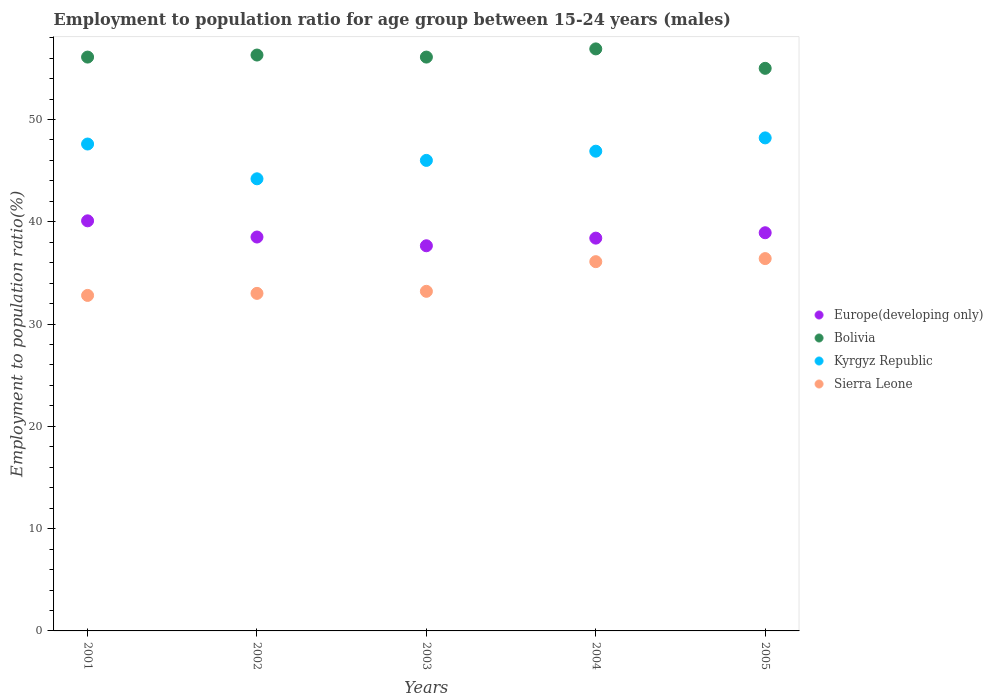What is the employment to population ratio in Sierra Leone in 2004?
Your answer should be very brief. 36.1. Across all years, what is the maximum employment to population ratio in Bolivia?
Your answer should be compact. 56.9. Across all years, what is the minimum employment to population ratio in Sierra Leone?
Offer a very short reply. 32.8. In which year was the employment to population ratio in Europe(developing only) maximum?
Provide a short and direct response. 2001. What is the total employment to population ratio in Kyrgyz Republic in the graph?
Make the answer very short. 232.9. What is the difference between the employment to population ratio in Kyrgyz Republic in 2001 and that in 2004?
Keep it short and to the point. 0.7. What is the difference between the employment to population ratio in Bolivia in 2001 and the employment to population ratio in Europe(developing only) in 2005?
Provide a short and direct response. 17.17. What is the average employment to population ratio in Bolivia per year?
Your answer should be compact. 56.08. In the year 2003, what is the difference between the employment to population ratio in Sierra Leone and employment to population ratio in Kyrgyz Republic?
Your answer should be very brief. -12.8. In how many years, is the employment to population ratio in Europe(developing only) greater than 24 %?
Keep it short and to the point. 5. What is the ratio of the employment to population ratio in Bolivia in 2002 to that in 2005?
Your response must be concise. 1.02. Is the employment to population ratio in Kyrgyz Republic in 2003 less than that in 2005?
Your answer should be very brief. Yes. What is the difference between the highest and the second highest employment to population ratio in Europe(developing only)?
Give a very brief answer. 1.16. What is the difference between the highest and the lowest employment to population ratio in Sierra Leone?
Offer a very short reply. 3.6. In how many years, is the employment to population ratio in Sierra Leone greater than the average employment to population ratio in Sierra Leone taken over all years?
Ensure brevity in your answer.  2. Is it the case that in every year, the sum of the employment to population ratio in Kyrgyz Republic and employment to population ratio in Europe(developing only)  is greater than the sum of employment to population ratio in Sierra Leone and employment to population ratio in Bolivia?
Ensure brevity in your answer.  No. What is the difference between two consecutive major ticks on the Y-axis?
Your response must be concise. 10. Where does the legend appear in the graph?
Make the answer very short. Center right. How many legend labels are there?
Your answer should be very brief. 4. How are the legend labels stacked?
Give a very brief answer. Vertical. What is the title of the graph?
Provide a short and direct response. Employment to population ratio for age group between 15-24 years (males). Does "Denmark" appear as one of the legend labels in the graph?
Provide a short and direct response. No. What is the label or title of the X-axis?
Your answer should be very brief. Years. What is the Employment to population ratio(%) of Europe(developing only) in 2001?
Your answer should be compact. 40.09. What is the Employment to population ratio(%) in Bolivia in 2001?
Give a very brief answer. 56.1. What is the Employment to population ratio(%) in Kyrgyz Republic in 2001?
Give a very brief answer. 47.6. What is the Employment to population ratio(%) in Sierra Leone in 2001?
Offer a very short reply. 32.8. What is the Employment to population ratio(%) of Europe(developing only) in 2002?
Give a very brief answer. 38.51. What is the Employment to population ratio(%) in Bolivia in 2002?
Make the answer very short. 56.3. What is the Employment to population ratio(%) of Kyrgyz Republic in 2002?
Keep it short and to the point. 44.2. What is the Employment to population ratio(%) of Sierra Leone in 2002?
Provide a succinct answer. 33. What is the Employment to population ratio(%) in Europe(developing only) in 2003?
Provide a short and direct response. 37.65. What is the Employment to population ratio(%) in Bolivia in 2003?
Provide a short and direct response. 56.1. What is the Employment to population ratio(%) of Sierra Leone in 2003?
Keep it short and to the point. 33.2. What is the Employment to population ratio(%) in Europe(developing only) in 2004?
Your answer should be compact. 38.4. What is the Employment to population ratio(%) of Bolivia in 2004?
Your response must be concise. 56.9. What is the Employment to population ratio(%) of Kyrgyz Republic in 2004?
Your answer should be very brief. 46.9. What is the Employment to population ratio(%) in Sierra Leone in 2004?
Your response must be concise. 36.1. What is the Employment to population ratio(%) of Europe(developing only) in 2005?
Your response must be concise. 38.93. What is the Employment to population ratio(%) in Bolivia in 2005?
Provide a short and direct response. 55. What is the Employment to population ratio(%) in Kyrgyz Republic in 2005?
Keep it short and to the point. 48.2. What is the Employment to population ratio(%) in Sierra Leone in 2005?
Provide a succinct answer. 36.4. Across all years, what is the maximum Employment to population ratio(%) in Europe(developing only)?
Offer a very short reply. 40.09. Across all years, what is the maximum Employment to population ratio(%) of Bolivia?
Offer a very short reply. 56.9. Across all years, what is the maximum Employment to population ratio(%) of Kyrgyz Republic?
Provide a short and direct response. 48.2. Across all years, what is the maximum Employment to population ratio(%) in Sierra Leone?
Your answer should be compact. 36.4. Across all years, what is the minimum Employment to population ratio(%) in Europe(developing only)?
Keep it short and to the point. 37.65. Across all years, what is the minimum Employment to population ratio(%) of Bolivia?
Your answer should be compact. 55. Across all years, what is the minimum Employment to population ratio(%) in Kyrgyz Republic?
Your answer should be compact. 44.2. Across all years, what is the minimum Employment to population ratio(%) of Sierra Leone?
Provide a succinct answer. 32.8. What is the total Employment to population ratio(%) of Europe(developing only) in the graph?
Provide a succinct answer. 193.58. What is the total Employment to population ratio(%) of Bolivia in the graph?
Provide a short and direct response. 280.4. What is the total Employment to population ratio(%) of Kyrgyz Republic in the graph?
Give a very brief answer. 232.9. What is the total Employment to population ratio(%) in Sierra Leone in the graph?
Your response must be concise. 171.5. What is the difference between the Employment to population ratio(%) of Europe(developing only) in 2001 and that in 2002?
Offer a terse response. 1.58. What is the difference between the Employment to population ratio(%) in Bolivia in 2001 and that in 2002?
Provide a short and direct response. -0.2. What is the difference between the Employment to population ratio(%) of Sierra Leone in 2001 and that in 2002?
Your response must be concise. -0.2. What is the difference between the Employment to population ratio(%) in Europe(developing only) in 2001 and that in 2003?
Offer a terse response. 2.44. What is the difference between the Employment to population ratio(%) in Kyrgyz Republic in 2001 and that in 2003?
Ensure brevity in your answer.  1.6. What is the difference between the Employment to population ratio(%) of Europe(developing only) in 2001 and that in 2004?
Give a very brief answer. 1.69. What is the difference between the Employment to population ratio(%) of Bolivia in 2001 and that in 2004?
Provide a short and direct response. -0.8. What is the difference between the Employment to population ratio(%) of Europe(developing only) in 2001 and that in 2005?
Keep it short and to the point. 1.16. What is the difference between the Employment to population ratio(%) of Bolivia in 2001 and that in 2005?
Your answer should be very brief. 1.1. What is the difference between the Employment to population ratio(%) of Kyrgyz Republic in 2001 and that in 2005?
Offer a very short reply. -0.6. What is the difference between the Employment to population ratio(%) in Sierra Leone in 2001 and that in 2005?
Your answer should be very brief. -3.6. What is the difference between the Employment to population ratio(%) in Europe(developing only) in 2002 and that in 2003?
Offer a very short reply. 0.86. What is the difference between the Employment to population ratio(%) of Sierra Leone in 2002 and that in 2003?
Provide a short and direct response. -0.2. What is the difference between the Employment to population ratio(%) of Europe(developing only) in 2002 and that in 2004?
Offer a very short reply. 0.11. What is the difference between the Employment to population ratio(%) in Kyrgyz Republic in 2002 and that in 2004?
Offer a terse response. -2.7. What is the difference between the Employment to population ratio(%) of Europe(developing only) in 2002 and that in 2005?
Your answer should be very brief. -0.42. What is the difference between the Employment to population ratio(%) of Kyrgyz Republic in 2002 and that in 2005?
Give a very brief answer. -4. What is the difference between the Employment to population ratio(%) in Europe(developing only) in 2003 and that in 2004?
Give a very brief answer. -0.75. What is the difference between the Employment to population ratio(%) in Europe(developing only) in 2003 and that in 2005?
Your answer should be compact. -1.27. What is the difference between the Employment to population ratio(%) of Bolivia in 2003 and that in 2005?
Offer a terse response. 1.1. What is the difference between the Employment to population ratio(%) in Kyrgyz Republic in 2003 and that in 2005?
Offer a very short reply. -2.2. What is the difference between the Employment to population ratio(%) in Europe(developing only) in 2004 and that in 2005?
Your response must be concise. -0.53. What is the difference between the Employment to population ratio(%) in Europe(developing only) in 2001 and the Employment to population ratio(%) in Bolivia in 2002?
Your response must be concise. -16.21. What is the difference between the Employment to population ratio(%) of Europe(developing only) in 2001 and the Employment to population ratio(%) of Kyrgyz Republic in 2002?
Provide a succinct answer. -4.11. What is the difference between the Employment to population ratio(%) in Europe(developing only) in 2001 and the Employment to population ratio(%) in Sierra Leone in 2002?
Ensure brevity in your answer.  7.09. What is the difference between the Employment to population ratio(%) of Bolivia in 2001 and the Employment to population ratio(%) of Kyrgyz Republic in 2002?
Your answer should be very brief. 11.9. What is the difference between the Employment to population ratio(%) in Bolivia in 2001 and the Employment to population ratio(%) in Sierra Leone in 2002?
Give a very brief answer. 23.1. What is the difference between the Employment to population ratio(%) in Kyrgyz Republic in 2001 and the Employment to population ratio(%) in Sierra Leone in 2002?
Your response must be concise. 14.6. What is the difference between the Employment to population ratio(%) in Europe(developing only) in 2001 and the Employment to population ratio(%) in Bolivia in 2003?
Your answer should be compact. -16.01. What is the difference between the Employment to population ratio(%) in Europe(developing only) in 2001 and the Employment to population ratio(%) in Kyrgyz Republic in 2003?
Provide a succinct answer. -5.91. What is the difference between the Employment to population ratio(%) in Europe(developing only) in 2001 and the Employment to population ratio(%) in Sierra Leone in 2003?
Provide a short and direct response. 6.89. What is the difference between the Employment to population ratio(%) in Bolivia in 2001 and the Employment to population ratio(%) in Sierra Leone in 2003?
Offer a terse response. 22.9. What is the difference between the Employment to population ratio(%) of Europe(developing only) in 2001 and the Employment to population ratio(%) of Bolivia in 2004?
Ensure brevity in your answer.  -16.81. What is the difference between the Employment to population ratio(%) in Europe(developing only) in 2001 and the Employment to population ratio(%) in Kyrgyz Republic in 2004?
Your answer should be very brief. -6.81. What is the difference between the Employment to population ratio(%) in Europe(developing only) in 2001 and the Employment to population ratio(%) in Sierra Leone in 2004?
Offer a terse response. 3.99. What is the difference between the Employment to population ratio(%) of Europe(developing only) in 2001 and the Employment to population ratio(%) of Bolivia in 2005?
Give a very brief answer. -14.91. What is the difference between the Employment to population ratio(%) in Europe(developing only) in 2001 and the Employment to population ratio(%) in Kyrgyz Republic in 2005?
Your answer should be compact. -8.11. What is the difference between the Employment to population ratio(%) of Europe(developing only) in 2001 and the Employment to population ratio(%) of Sierra Leone in 2005?
Your response must be concise. 3.69. What is the difference between the Employment to population ratio(%) of Bolivia in 2001 and the Employment to population ratio(%) of Kyrgyz Republic in 2005?
Provide a short and direct response. 7.9. What is the difference between the Employment to population ratio(%) of Europe(developing only) in 2002 and the Employment to population ratio(%) of Bolivia in 2003?
Your answer should be very brief. -17.59. What is the difference between the Employment to population ratio(%) of Europe(developing only) in 2002 and the Employment to population ratio(%) of Kyrgyz Republic in 2003?
Provide a short and direct response. -7.49. What is the difference between the Employment to population ratio(%) in Europe(developing only) in 2002 and the Employment to population ratio(%) in Sierra Leone in 2003?
Provide a succinct answer. 5.31. What is the difference between the Employment to population ratio(%) in Bolivia in 2002 and the Employment to population ratio(%) in Kyrgyz Republic in 2003?
Your answer should be compact. 10.3. What is the difference between the Employment to population ratio(%) of Bolivia in 2002 and the Employment to population ratio(%) of Sierra Leone in 2003?
Provide a succinct answer. 23.1. What is the difference between the Employment to population ratio(%) in Europe(developing only) in 2002 and the Employment to population ratio(%) in Bolivia in 2004?
Keep it short and to the point. -18.39. What is the difference between the Employment to population ratio(%) in Europe(developing only) in 2002 and the Employment to population ratio(%) in Kyrgyz Republic in 2004?
Your answer should be very brief. -8.39. What is the difference between the Employment to population ratio(%) in Europe(developing only) in 2002 and the Employment to population ratio(%) in Sierra Leone in 2004?
Your response must be concise. 2.41. What is the difference between the Employment to population ratio(%) in Bolivia in 2002 and the Employment to population ratio(%) in Sierra Leone in 2004?
Make the answer very short. 20.2. What is the difference between the Employment to population ratio(%) of Europe(developing only) in 2002 and the Employment to population ratio(%) of Bolivia in 2005?
Offer a terse response. -16.49. What is the difference between the Employment to population ratio(%) in Europe(developing only) in 2002 and the Employment to population ratio(%) in Kyrgyz Republic in 2005?
Your answer should be very brief. -9.69. What is the difference between the Employment to population ratio(%) in Europe(developing only) in 2002 and the Employment to population ratio(%) in Sierra Leone in 2005?
Provide a succinct answer. 2.11. What is the difference between the Employment to population ratio(%) in Europe(developing only) in 2003 and the Employment to population ratio(%) in Bolivia in 2004?
Your answer should be compact. -19.25. What is the difference between the Employment to population ratio(%) of Europe(developing only) in 2003 and the Employment to population ratio(%) of Kyrgyz Republic in 2004?
Give a very brief answer. -9.25. What is the difference between the Employment to population ratio(%) in Europe(developing only) in 2003 and the Employment to population ratio(%) in Sierra Leone in 2004?
Offer a very short reply. 1.55. What is the difference between the Employment to population ratio(%) in Bolivia in 2003 and the Employment to population ratio(%) in Kyrgyz Republic in 2004?
Provide a succinct answer. 9.2. What is the difference between the Employment to population ratio(%) of Bolivia in 2003 and the Employment to population ratio(%) of Sierra Leone in 2004?
Your answer should be very brief. 20. What is the difference between the Employment to population ratio(%) of Europe(developing only) in 2003 and the Employment to population ratio(%) of Bolivia in 2005?
Ensure brevity in your answer.  -17.35. What is the difference between the Employment to population ratio(%) of Europe(developing only) in 2003 and the Employment to population ratio(%) of Kyrgyz Republic in 2005?
Ensure brevity in your answer.  -10.55. What is the difference between the Employment to population ratio(%) of Europe(developing only) in 2003 and the Employment to population ratio(%) of Sierra Leone in 2005?
Your answer should be very brief. 1.25. What is the difference between the Employment to population ratio(%) of Bolivia in 2003 and the Employment to population ratio(%) of Kyrgyz Republic in 2005?
Offer a terse response. 7.9. What is the difference between the Employment to population ratio(%) of Bolivia in 2003 and the Employment to population ratio(%) of Sierra Leone in 2005?
Provide a short and direct response. 19.7. What is the difference between the Employment to population ratio(%) of Europe(developing only) in 2004 and the Employment to population ratio(%) of Bolivia in 2005?
Your response must be concise. -16.6. What is the difference between the Employment to population ratio(%) in Europe(developing only) in 2004 and the Employment to population ratio(%) in Kyrgyz Republic in 2005?
Your answer should be very brief. -9.8. What is the difference between the Employment to population ratio(%) in Europe(developing only) in 2004 and the Employment to population ratio(%) in Sierra Leone in 2005?
Give a very brief answer. 2. What is the difference between the Employment to population ratio(%) of Bolivia in 2004 and the Employment to population ratio(%) of Kyrgyz Republic in 2005?
Ensure brevity in your answer.  8.7. What is the difference between the Employment to population ratio(%) in Bolivia in 2004 and the Employment to population ratio(%) in Sierra Leone in 2005?
Your response must be concise. 20.5. What is the difference between the Employment to population ratio(%) in Kyrgyz Republic in 2004 and the Employment to population ratio(%) in Sierra Leone in 2005?
Give a very brief answer. 10.5. What is the average Employment to population ratio(%) of Europe(developing only) per year?
Keep it short and to the point. 38.72. What is the average Employment to population ratio(%) in Bolivia per year?
Provide a short and direct response. 56.08. What is the average Employment to population ratio(%) in Kyrgyz Republic per year?
Make the answer very short. 46.58. What is the average Employment to population ratio(%) in Sierra Leone per year?
Give a very brief answer. 34.3. In the year 2001, what is the difference between the Employment to population ratio(%) in Europe(developing only) and Employment to population ratio(%) in Bolivia?
Provide a succinct answer. -16.01. In the year 2001, what is the difference between the Employment to population ratio(%) of Europe(developing only) and Employment to population ratio(%) of Kyrgyz Republic?
Give a very brief answer. -7.51. In the year 2001, what is the difference between the Employment to population ratio(%) in Europe(developing only) and Employment to population ratio(%) in Sierra Leone?
Offer a very short reply. 7.29. In the year 2001, what is the difference between the Employment to population ratio(%) in Bolivia and Employment to population ratio(%) in Sierra Leone?
Offer a terse response. 23.3. In the year 2002, what is the difference between the Employment to population ratio(%) of Europe(developing only) and Employment to population ratio(%) of Bolivia?
Ensure brevity in your answer.  -17.79. In the year 2002, what is the difference between the Employment to population ratio(%) of Europe(developing only) and Employment to population ratio(%) of Kyrgyz Republic?
Make the answer very short. -5.69. In the year 2002, what is the difference between the Employment to population ratio(%) of Europe(developing only) and Employment to population ratio(%) of Sierra Leone?
Your response must be concise. 5.51. In the year 2002, what is the difference between the Employment to population ratio(%) in Bolivia and Employment to population ratio(%) in Kyrgyz Republic?
Make the answer very short. 12.1. In the year 2002, what is the difference between the Employment to population ratio(%) in Bolivia and Employment to population ratio(%) in Sierra Leone?
Ensure brevity in your answer.  23.3. In the year 2002, what is the difference between the Employment to population ratio(%) of Kyrgyz Republic and Employment to population ratio(%) of Sierra Leone?
Your response must be concise. 11.2. In the year 2003, what is the difference between the Employment to population ratio(%) in Europe(developing only) and Employment to population ratio(%) in Bolivia?
Your answer should be compact. -18.45. In the year 2003, what is the difference between the Employment to population ratio(%) in Europe(developing only) and Employment to population ratio(%) in Kyrgyz Republic?
Ensure brevity in your answer.  -8.35. In the year 2003, what is the difference between the Employment to population ratio(%) in Europe(developing only) and Employment to population ratio(%) in Sierra Leone?
Offer a very short reply. 4.45. In the year 2003, what is the difference between the Employment to population ratio(%) in Bolivia and Employment to population ratio(%) in Sierra Leone?
Offer a very short reply. 22.9. In the year 2004, what is the difference between the Employment to population ratio(%) in Europe(developing only) and Employment to population ratio(%) in Bolivia?
Offer a terse response. -18.5. In the year 2004, what is the difference between the Employment to population ratio(%) in Europe(developing only) and Employment to population ratio(%) in Kyrgyz Republic?
Provide a succinct answer. -8.5. In the year 2004, what is the difference between the Employment to population ratio(%) in Europe(developing only) and Employment to population ratio(%) in Sierra Leone?
Provide a short and direct response. 2.3. In the year 2004, what is the difference between the Employment to population ratio(%) in Bolivia and Employment to population ratio(%) in Sierra Leone?
Offer a very short reply. 20.8. In the year 2005, what is the difference between the Employment to population ratio(%) in Europe(developing only) and Employment to population ratio(%) in Bolivia?
Provide a succinct answer. -16.07. In the year 2005, what is the difference between the Employment to population ratio(%) in Europe(developing only) and Employment to population ratio(%) in Kyrgyz Republic?
Ensure brevity in your answer.  -9.27. In the year 2005, what is the difference between the Employment to population ratio(%) in Europe(developing only) and Employment to population ratio(%) in Sierra Leone?
Your response must be concise. 2.53. In the year 2005, what is the difference between the Employment to population ratio(%) in Kyrgyz Republic and Employment to population ratio(%) in Sierra Leone?
Make the answer very short. 11.8. What is the ratio of the Employment to population ratio(%) in Europe(developing only) in 2001 to that in 2002?
Provide a succinct answer. 1.04. What is the ratio of the Employment to population ratio(%) of Kyrgyz Republic in 2001 to that in 2002?
Keep it short and to the point. 1.08. What is the ratio of the Employment to population ratio(%) in Sierra Leone in 2001 to that in 2002?
Your response must be concise. 0.99. What is the ratio of the Employment to population ratio(%) in Europe(developing only) in 2001 to that in 2003?
Provide a succinct answer. 1.06. What is the ratio of the Employment to population ratio(%) of Kyrgyz Republic in 2001 to that in 2003?
Ensure brevity in your answer.  1.03. What is the ratio of the Employment to population ratio(%) of Sierra Leone in 2001 to that in 2003?
Your answer should be very brief. 0.99. What is the ratio of the Employment to population ratio(%) of Europe(developing only) in 2001 to that in 2004?
Give a very brief answer. 1.04. What is the ratio of the Employment to population ratio(%) of Bolivia in 2001 to that in 2004?
Your answer should be compact. 0.99. What is the ratio of the Employment to population ratio(%) in Kyrgyz Republic in 2001 to that in 2004?
Provide a succinct answer. 1.01. What is the ratio of the Employment to population ratio(%) in Sierra Leone in 2001 to that in 2004?
Your response must be concise. 0.91. What is the ratio of the Employment to population ratio(%) in Europe(developing only) in 2001 to that in 2005?
Offer a terse response. 1.03. What is the ratio of the Employment to population ratio(%) in Kyrgyz Republic in 2001 to that in 2005?
Give a very brief answer. 0.99. What is the ratio of the Employment to population ratio(%) in Sierra Leone in 2001 to that in 2005?
Ensure brevity in your answer.  0.9. What is the ratio of the Employment to population ratio(%) in Europe(developing only) in 2002 to that in 2003?
Ensure brevity in your answer.  1.02. What is the ratio of the Employment to population ratio(%) in Bolivia in 2002 to that in 2003?
Your response must be concise. 1. What is the ratio of the Employment to population ratio(%) of Kyrgyz Republic in 2002 to that in 2003?
Provide a short and direct response. 0.96. What is the ratio of the Employment to population ratio(%) in Sierra Leone in 2002 to that in 2003?
Offer a terse response. 0.99. What is the ratio of the Employment to population ratio(%) of Europe(developing only) in 2002 to that in 2004?
Your answer should be very brief. 1. What is the ratio of the Employment to population ratio(%) of Kyrgyz Republic in 2002 to that in 2004?
Give a very brief answer. 0.94. What is the ratio of the Employment to population ratio(%) of Sierra Leone in 2002 to that in 2004?
Your answer should be very brief. 0.91. What is the ratio of the Employment to population ratio(%) of Europe(developing only) in 2002 to that in 2005?
Provide a succinct answer. 0.99. What is the ratio of the Employment to population ratio(%) of Bolivia in 2002 to that in 2005?
Your answer should be compact. 1.02. What is the ratio of the Employment to population ratio(%) in Kyrgyz Republic in 2002 to that in 2005?
Give a very brief answer. 0.92. What is the ratio of the Employment to population ratio(%) in Sierra Leone in 2002 to that in 2005?
Your answer should be compact. 0.91. What is the ratio of the Employment to population ratio(%) of Europe(developing only) in 2003 to that in 2004?
Your answer should be very brief. 0.98. What is the ratio of the Employment to population ratio(%) in Bolivia in 2003 to that in 2004?
Provide a succinct answer. 0.99. What is the ratio of the Employment to population ratio(%) in Kyrgyz Republic in 2003 to that in 2004?
Ensure brevity in your answer.  0.98. What is the ratio of the Employment to population ratio(%) in Sierra Leone in 2003 to that in 2004?
Ensure brevity in your answer.  0.92. What is the ratio of the Employment to population ratio(%) of Europe(developing only) in 2003 to that in 2005?
Keep it short and to the point. 0.97. What is the ratio of the Employment to population ratio(%) of Kyrgyz Republic in 2003 to that in 2005?
Your response must be concise. 0.95. What is the ratio of the Employment to population ratio(%) of Sierra Leone in 2003 to that in 2005?
Give a very brief answer. 0.91. What is the ratio of the Employment to population ratio(%) in Europe(developing only) in 2004 to that in 2005?
Make the answer very short. 0.99. What is the ratio of the Employment to population ratio(%) of Bolivia in 2004 to that in 2005?
Provide a succinct answer. 1.03. What is the difference between the highest and the second highest Employment to population ratio(%) of Europe(developing only)?
Your answer should be compact. 1.16. What is the difference between the highest and the second highest Employment to population ratio(%) in Bolivia?
Ensure brevity in your answer.  0.6. What is the difference between the highest and the second highest Employment to population ratio(%) in Kyrgyz Republic?
Keep it short and to the point. 0.6. What is the difference between the highest and the lowest Employment to population ratio(%) in Europe(developing only)?
Give a very brief answer. 2.44. What is the difference between the highest and the lowest Employment to population ratio(%) in Kyrgyz Republic?
Provide a short and direct response. 4. 